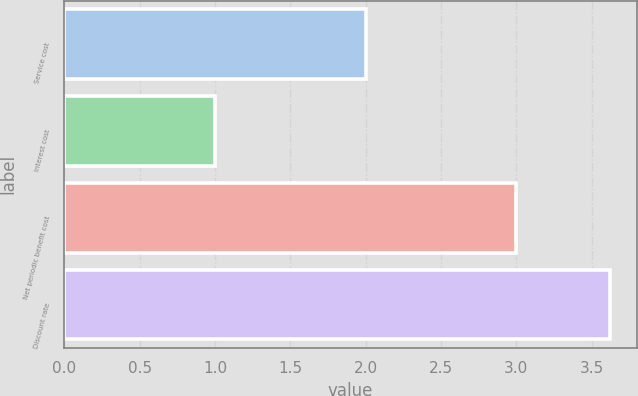<chart> <loc_0><loc_0><loc_500><loc_500><bar_chart><fcel>Service cost<fcel>Interest cost<fcel>Net periodic benefit cost<fcel>Discount rate<nl><fcel>2<fcel>1<fcel>3<fcel>3.62<nl></chart> 